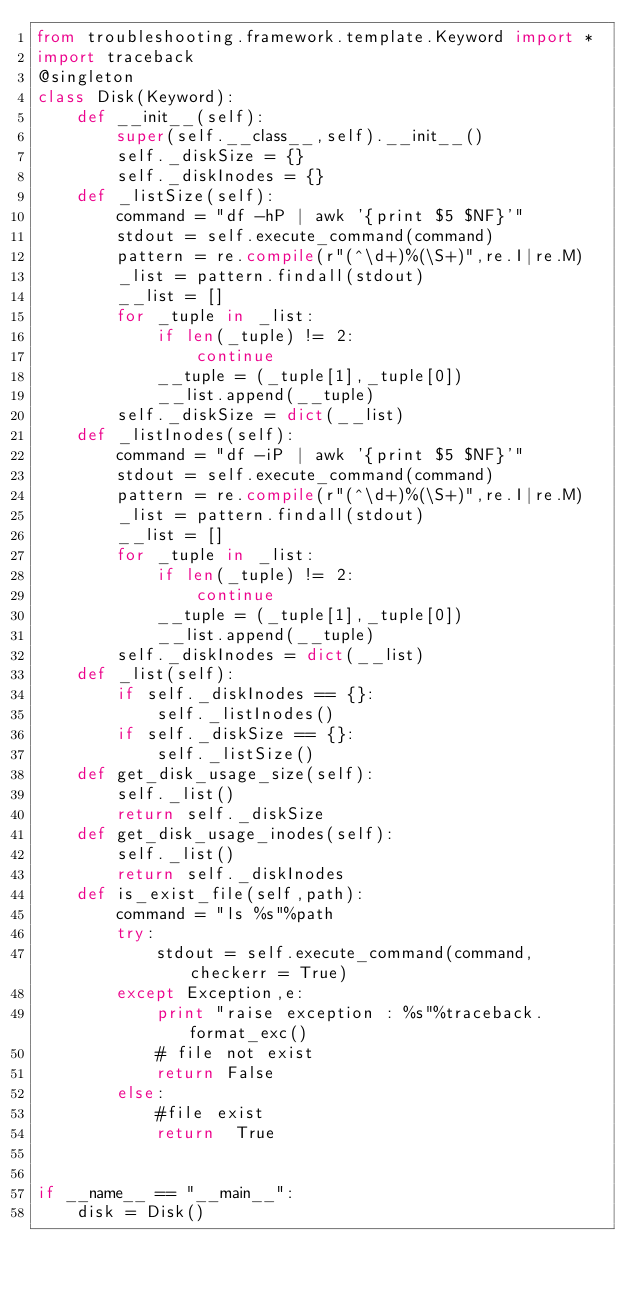Convert code to text. <code><loc_0><loc_0><loc_500><loc_500><_Python_>from troubleshooting.framework.template.Keyword import *
import traceback
@singleton
class Disk(Keyword):
    def __init__(self):
        super(self.__class__,self).__init__()
        self._diskSize = {}
        self._diskInodes = {}
    def _listSize(self):
        command = "df -hP | awk '{print $5 $NF}'"
        stdout = self.execute_command(command)
        pattern = re.compile(r"(^\d+)%(\S+)",re.I|re.M)
        _list = pattern.findall(stdout)
        __list = []
        for _tuple in _list:
            if len(_tuple) != 2:
                continue
            __tuple = (_tuple[1],_tuple[0])
            __list.append(__tuple)
        self._diskSize = dict(__list)
    def _listInodes(self):
        command = "df -iP | awk '{print $5 $NF}'"
        stdout = self.execute_command(command)
        pattern = re.compile(r"(^\d+)%(\S+)",re.I|re.M)
        _list = pattern.findall(stdout)
        __list = []
        for _tuple in _list:
            if len(_tuple) != 2:
                continue
            __tuple = (_tuple[1],_tuple[0])
            __list.append(__tuple)
        self._diskInodes = dict(__list)
    def _list(self):
        if self._diskInodes == {}:
            self._listInodes()
        if self._diskSize == {}:
            self._listSize()
    def get_disk_usage_size(self):
        self._list()
        return self._diskSize
    def get_disk_usage_inodes(self):
        self._list()
        return self._diskInodes
    def is_exist_file(self,path):
        command = "ls %s"%path
        try:
            stdout = self.execute_command(command,checkerr = True)
        except Exception,e:
            print "raise exception : %s"%traceback.format_exc()
            # file not exist
            return False
        else:
            #file exist
            return  True


if __name__ == "__main__":
    disk = Disk()

</code> 